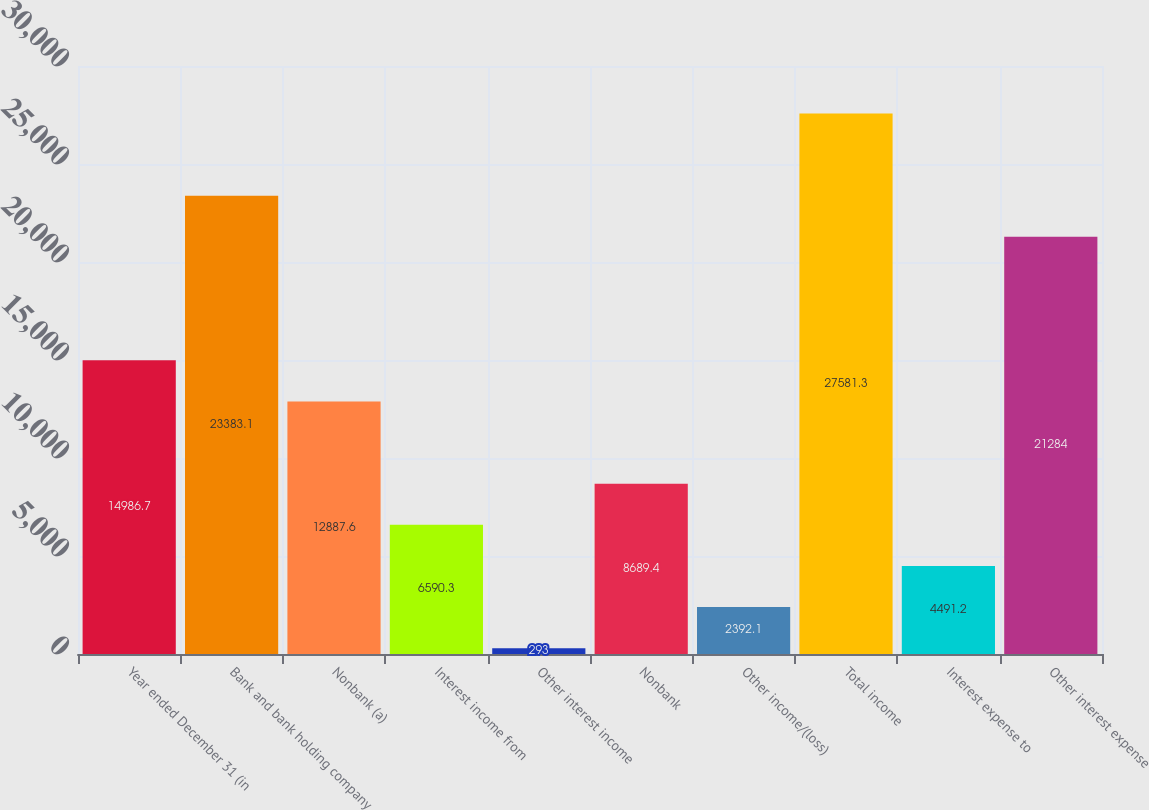<chart> <loc_0><loc_0><loc_500><loc_500><bar_chart><fcel>Year ended December 31 (in<fcel>Bank and bank holding company<fcel>Nonbank (a)<fcel>Interest income from<fcel>Other interest income<fcel>Nonbank<fcel>Other income/(loss)<fcel>Total income<fcel>Interest expense to<fcel>Other interest expense<nl><fcel>14986.7<fcel>23383.1<fcel>12887.6<fcel>6590.3<fcel>293<fcel>8689.4<fcel>2392.1<fcel>27581.3<fcel>4491.2<fcel>21284<nl></chart> 